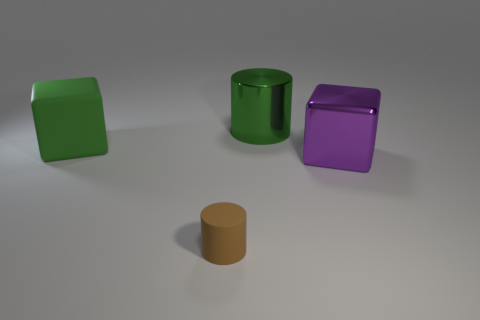Are there an equal number of purple objects to the left of the big green rubber thing and tiny cyan shiny balls?
Provide a short and direct response. Yes. How many large cylinders have the same color as the large matte object?
Make the answer very short. 1. What color is the other big thing that is the same shape as the brown thing?
Make the answer very short. Green. Is the size of the brown cylinder the same as the green cylinder?
Your answer should be very brief. No. Are there the same number of big metallic blocks that are behind the green metallic cylinder and purple metal objects that are on the left side of the small matte thing?
Offer a terse response. Yes. Are there any tiny cylinders?
Keep it short and to the point. Yes. There is a green object that is the same shape as the big purple metal thing; what is its size?
Your answer should be very brief. Large. There is a block in front of the green block; what is its size?
Provide a succinct answer. Large. Is the number of large objects in front of the matte cube greater than the number of green cubes?
Provide a short and direct response. No. There is a big purple object; what shape is it?
Give a very brief answer. Cube. 